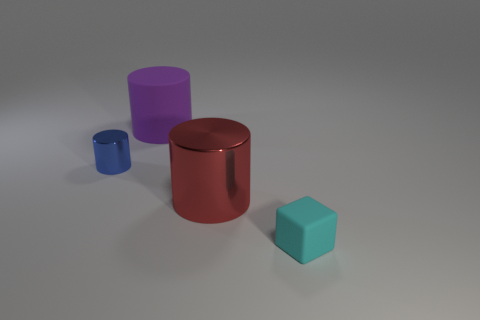What number of cylinders are cyan things or red objects?
Your answer should be very brief. 1. What number of big purple matte objects have the same shape as the small cyan thing?
Your response must be concise. 0. Is the number of small cyan matte things that are on the right side of the tiny cyan thing greater than the number of matte cubes behind the large matte object?
Your answer should be very brief. No. There is a large thing that is in front of the big matte cylinder; is its color the same as the big matte object?
Provide a short and direct response. No. The blue object has what size?
Make the answer very short. Small. What material is the cylinder that is the same size as the cyan cube?
Your answer should be very brief. Metal. The metallic cylinder right of the small blue metal thing is what color?
Give a very brief answer. Red. What number of big purple matte things are there?
Keep it short and to the point. 1. There is a metallic cylinder to the left of the large cylinder behind the small blue thing; are there any large metal cylinders that are left of it?
Make the answer very short. No. There is another object that is the same size as the red object; what shape is it?
Give a very brief answer. Cylinder. 